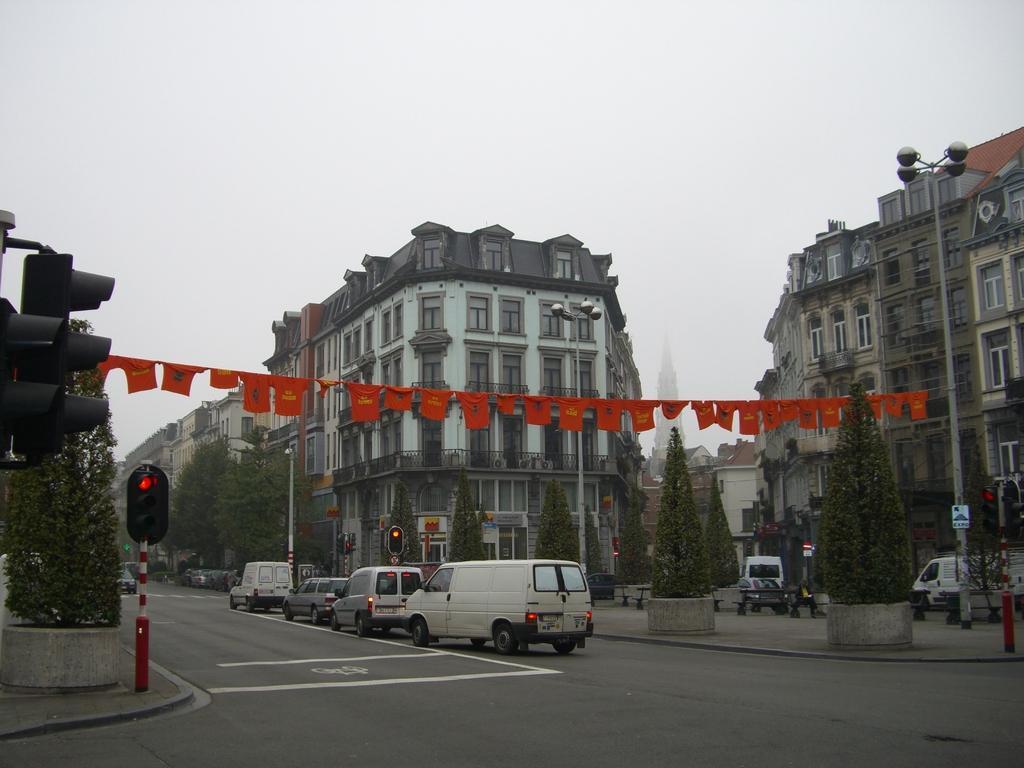Please provide a concise description of this image. In this image I can see buildings and street light poles and trees and at the top I can see the sky in the middle I can see road, on the road I can see vehicles and traffic signal light visible and I can see a orange color flags attached to the rope in the middle. 